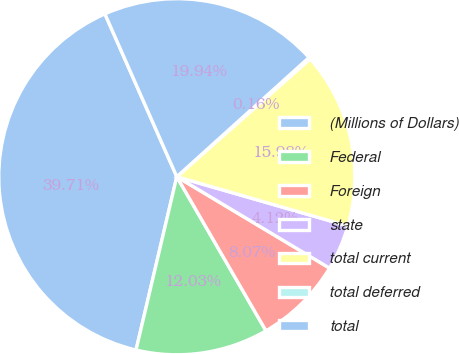Convert chart. <chart><loc_0><loc_0><loc_500><loc_500><pie_chart><fcel>(Millions of Dollars)<fcel>Federal<fcel>Foreign<fcel>state<fcel>total current<fcel>total deferred<fcel>total<nl><fcel>39.71%<fcel>12.03%<fcel>8.07%<fcel>4.12%<fcel>15.98%<fcel>0.16%<fcel>19.94%<nl></chart> 